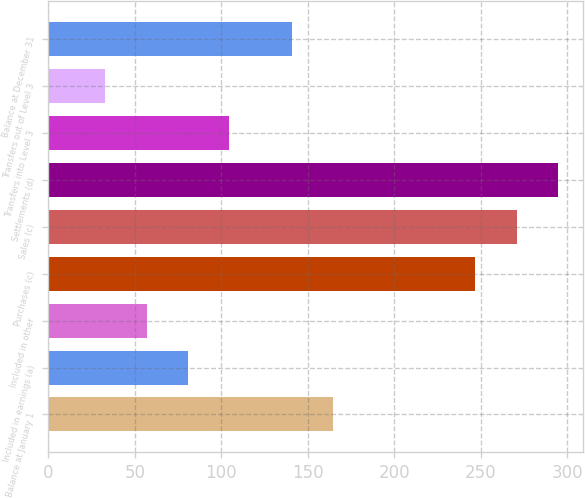<chart> <loc_0><loc_0><loc_500><loc_500><bar_chart><fcel>Balance at January 1<fcel>Included in earnings (a)<fcel>Included in other<fcel>Purchases (c)<fcel>Sales (c)<fcel>Settlements (d)<fcel>Transfers into Level 3<fcel>Transfers out of Level 3<fcel>Balance at December 31<nl><fcel>164.8<fcel>80.6<fcel>56.8<fcel>247<fcel>270.8<fcel>294.6<fcel>104.4<fcel>33<fcel>141<nl></chart> 